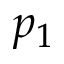Convert formula to latex. <formula><loc_0><loc_0><loc_500><loc_500>p _ { 1 }</formula> 